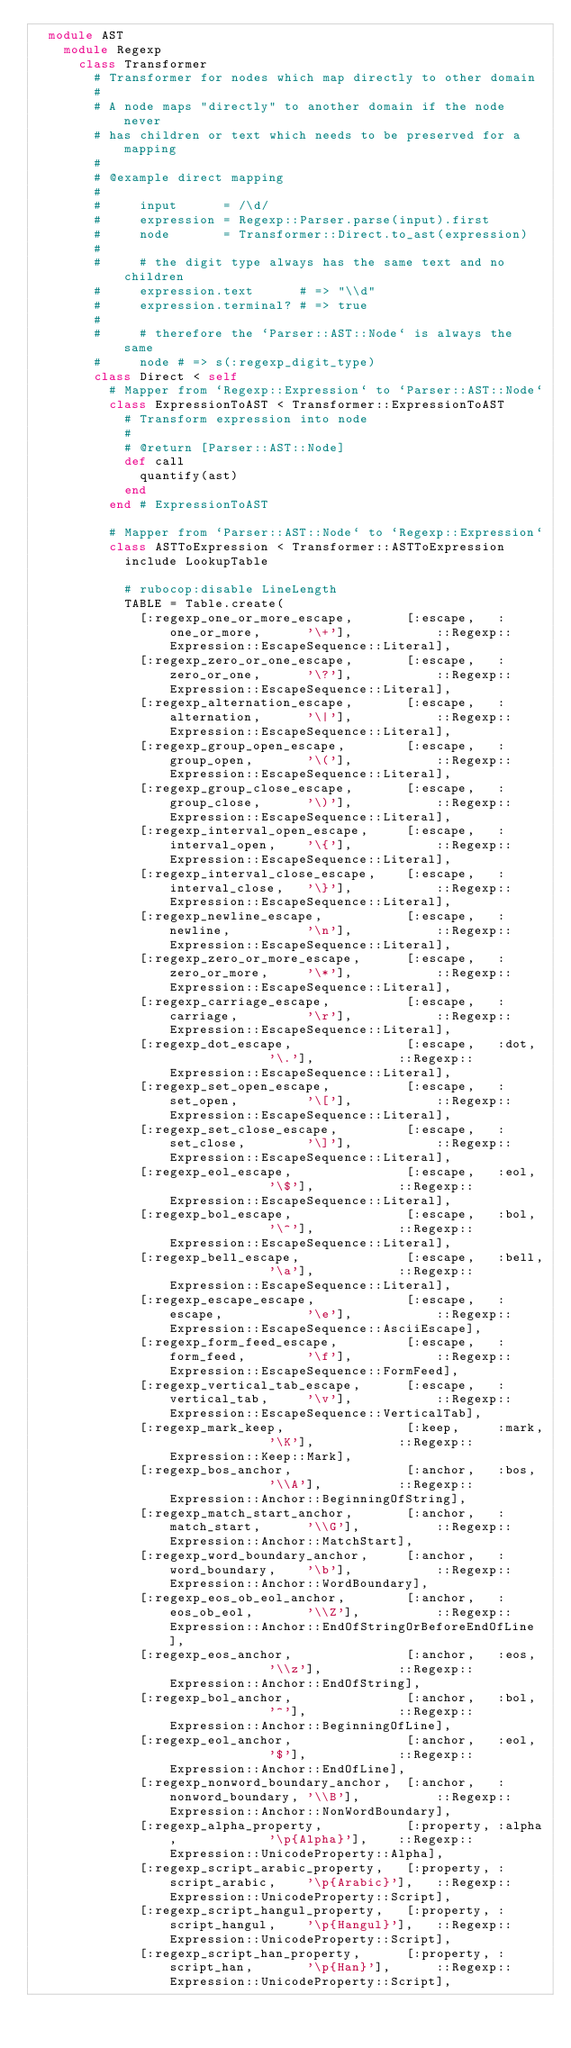Convert code to text. <code><loc_0><loc_0><loc_500><loc_500><_Ruby_>  module AST
    module Regexp
      class Transformer
        # Transformer for nodes which map directly to other domain
        #
        # A node maps "directly" to another domain if the node never
        # has children or text which needs to be preserved for a mapping
        #
        # @example direct mapping
        #
        #     input      = /\d/
        #     expression = Regexp::Parser.parse(input).first
        #     node       = Transformer::Direct.to_ast(expression)
        #
        #     # the digit type always has the same text and no children
        #     expression.text      # => "\\d"
        #     expression.terminal? # => true
        #
        #     # therefore the `Parser::AST::Node` is always the same
        #     node # => s(:regexp_digit_type)
        class Direct < self
          # Mapper from `Regexp::Expression` to `Parser::AST::Node`
          class ExpressionToAST < Transformer::ExpressionToAST
            # Transform expression into node
            #
            # @return [Parser::AST::Node]
            def call
              quantify(ast)
            end
          end # ExpressionToAST

          # Mapper from `Parser::AST::Node` to `Regexp::Expression`
          class ASTToExpression < Transformer::ASTToExpression
            include LookupTable

            # rubocop:disable LineLength
            TABLE = Table.create(
              [:regexp_one_or_more_escape,       [:escape,   :one_or_more,      '\+'],           ::Regexp::Expression::EscapeSequence::Literal],
              [:regexp_zero_or_one_escape,       [:escape,   :zero_or_one,      '\?'],           ::Regexp::Expression::EscapeSequence::Literal],
              [:regexp_alternation_escape,       [:escape,   :alternation,      '\|'],           ::Regexp::Expression::EscapeSequence::Literal],
              [:regexp_group_open_escape,        [:escape,   :group_open,       '\('],           ::Regexp::Expression::EscapeSequence::Literal],
              [:regexp_group_close_escape,       [:escape,   :group_close,      '\)'],           ::Regexp::Expression::EscapeSequence::Literal],
              [:regexp_interval_open_escape,     [:escape,   :interval_open,    '\{'],           ::Regexp::Expression::EscapeSequence::Literal],
              [:regexp_interval_close_escape,    [:escape,   :interval_close,   '\}'],           ::Regexp::Expression::EscapeSequence::Literal],
              [:regexp_newline_escape,           [:escape,   :newline,          '\n'],           ::Regexp::Expression::EscapeSequence::Literal],
              [:regexp_zero_or_more_escape,      [:escape,   :zero_or_more,     '\*'],           ::Regexp::Expression::EscapeSequence::Literal],
              [:regexp_carriage_escape,          [:escape,   :carriage,         '\r'],           ::Regexp::Expression::EscapeSequence::Literal],
              [:regexp_dot_escape,               [:escape,   :dot,              '\.'],           ::Regexp::Expression::EscapeSequence::Literal],
              [:regexp_set_open_escape,          [:escape,   :set_open,         '\['],           ::Regexp::Expression::EscapeSequence::Literal],
              [:regexp_set_close_escape,         [:escape,   :set_close,        '\]'],           ::Regexp::Expression::EscapeSequence::Literal],
              [:regexp_eol_escape,               [:escape,   :eol,              '\$'],           ::Regexp::Expression::EscapeSequence::Literal],
              [:regexp_bol_escape,               [:escape,   :bol,              '\^'],           ::Regexp::Expression::EscapeSequence::Literal],
              [:regexp_bell_escape,              [:escape,   :bell,             '\a'],           ::Regexp::Expression::EscapeSequence::Literal],
              [:regexp_escape_escape,            [:escape,   :escape,           '\e'],           ::Regexp::Expression::EscapeSequence::AsciiEscape],
              [:regexp_form_feed_escape,         [:escape,   :form_feed,        '\f'],           ::Regexp::Expression::EscapeSequence::FormFeed],
              [:regexp_vertical_tab_escape,      [:escape,   :vertical_tab,     '\v'],           ::Regexp::Expression::EscapeSequence::VerticalTab],
              [:regexp_mark_keep,                [:keep,     :mark,             '\K'],           ::Regexp::Expression::Keep::Mark],
              [:regexp_bos_anchor,               [:anchor,   :bos,              '\\A'],          ::Regexp::Expression::Anchor::BeginningOfString],
              [:regexp_match_start_anchor,       [:anchor,   :match_start,      '\\G'],          ::Regexp::Expression::Anchor::MatchStart],
              [:regexp_word_boundary_anchor,     [:anchor,   :word_boundary,    '\b'],           ::Regexp::Expression::Anchor::WordBoundary],
              [:regexp_eos_ob_eol_anchor,        [:anchor,   :eos_ob_eol,       '\\Z'],          ::Regexp::Expression::Anchor::EndOfStringOrBeforeEndOfLine],
              [:regexp_eos_anchor,               [:anchor,   :eos,              '\\z'],          ::Regexp::Expression::Anchor::EndOfString],
              [:regexp_bol_anchor,               [:anchor,   :bol,              '^'],            ::Regexp::Expression::Anchor::BeginningOfLine],
              [:regexp_eol_anchor,               [:anchor,   :eol,              '$'],            ::Regexp::Expression::Anchor::EndOfLine],
              [:regexp_nonword_boundary_anchor,  [:anchor,   :nonword_boundary, '\\B'],          ::Regexp::Expression::Anchor::NonWordBoundary],
              [:regexp_alpha_property,           [:property, :alpha,            '\p{Alpha}'],    ::Regexp::Expression::UnicodeProperty::Alpha],
              [:regexp_script_arabic_property,   [:property, :script_arabic,    '\p{Arabic}'],   ::Regexp::Expression::UnicodeProperty::Script],
              [:regexp_script_hangul_property,   [:property, :script_hangul,    '\p{Hangul}'],   ::Regexp::Expression::UnicodeProperty::Script],
              [:regexp_script_han_property,      [:property, :script_han,       '\p{Han}'],      ::Regexp::Expression::UnicodeProperty::Script],</code> 